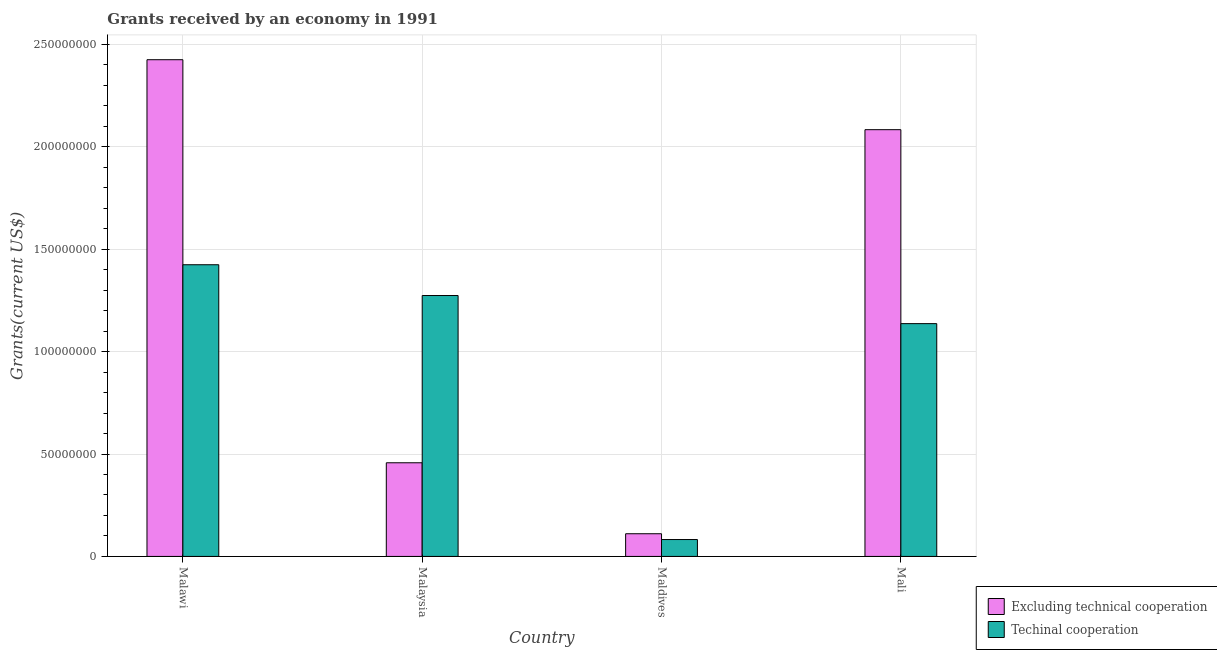Are the number of bars on each tick of the X-axis equal?
Your answer should be very brief. Yes. What is the label of the 2nd group of bars from the left?
Keep it short and to the point. Malaysia. What is the amount of grants received(excluding technical cooperation) in Mali?
Give a very brief answer. 2.08e+08. Across all countries, what is the maximum amount of grants received(excluding technical cooperation)?
Give a very brief answer. 2.43e+08. Across all countries, what is the minimum amount of grants received(including technical cooperation)?
Your answer should be compact. 8.25e+06. In which country was the amount of grants received(including technical cooperation) maximum?
Keep it short and to the point. Malawi. In which country was the amount of grants received(excluding technical cooperation) minimum?
Offer a very short reply. Maldives. What is the total amount of grants received(excluding technical cooperation) in the graph?
Provide a succinct answer. 5.08e+08. What is the difference between the amount of grants received(including technical cooperation) in Malaysia and that in Maldives?
Keep it short and to the point. 1.19e+08. What is the difference between the amount of grants received(excluding technical cooperation) in Maldives and the amount of grants received(including technical cooperation) in Mali?
Ensure brevity in your answer.  -1.03e+08. What is the average amount of grants received(including technical cooperation) per country?
Provide a succinct answer. 9.80e+07. What is the difference between the amount of grants received(excluding technical cooperation) and amount of grants received(including technical cooperation) in Mali?
Your answer should be compact. 9.47e+07. In how many countries, is the amount of grants received(excluding technical cooperation) greater than 190000000 US$?
Offer a terse response. 2. What is the ratio of the amount of grants received(including technical cooperation) in Malawi to that in Mali?
Provide a short and direct response. 1.25. Is the amount of grants received(including technical cooperation) in Malawi less than that in Mali?
Your response must be concise. No. What is the difference between the highest and the second highest amount of grants received(excluding technical cooperation)?
Your answer should be very brief. 3.42e+07. What is the difference between the highest and the lowest amount of grants received(including technical cooperation)?
Your response must be concise. 1.34e+08. What does the 1st bar from the left in Maldives represents?
Ensure brevity in your answer.  Excluding technical cooperation. What does the 2nd bar from the right in Malaysia represents?
Provide a succinct answer. Excluding technical cooperation. How many bars are there?
Ensure brevity in your answer.  8. Are all the bars in the graph horizontal?
Keep it short and to the point. No. How many countries are there in the graph?
Your response must be concise. 4. Are the values on the major ticks of Y-axis written in scientific E-notation?
Ensure brevity in your answer.  No. Does the graph contain any zero values?
Offer a very short reply. No. Where does the legend appear in the graph?
Your answer should be very brief. Bottom right. How are the legend labels stacked?
Provide a short and direct response. Vertical. What is the title of the graph?
Your answer should be compact. Grants received by an economy in 1991. What is the label or title of the Y-axis?
Ensure brevity in your answer.  Grants(current US$). What is the Grants(current US$) in Excluding technical cooperation in Malawi?
Offer a very short reply. 2.43e+08. What is the Grants(current US$) in Techinal cooperation in Malawi?
Ensure brevity in your answer.  1.42e+08. What is the Grants(current US$) of Excluding technical cooperation in Malaysia?
Keep it short and to the point. 4.57e+07. What is the Grants(current US$) in Techinal cooperation in Malaysia?
Keep it short and to the point. 1.27e+08. What is the Grants(current US$) in Excluding technical cooperation in Maldives?
Offer a terse response. 1.11e+07. What is the Grants(current US$) of Techinal cooperation in Maldives?
Provide a succinct answer. 8.25e+06. What is the Grants(current US$) of Excluding technical cooperation in Mali?
Your answer should be compact. 2.08e+08. What is the Grants(current US$) in Techinal cooperation in Mali?
Make the answer very short. 1.14e+08. Across all countries, what is the maximum Grants(current US$) in Excluding technical cooperation?
Your response must be concise. 2.43e+08. Across all countries, what is the maximum Grants(current US$) of Techinal cooperation?
Ensure brevity in your answer.  1.42e+08. Across all countries, what is the minimum Grants(current US$) in Excluding technical cooperation?
Give a very brief answer. 1.11e+07. Across all countries, what is the minimum Grants(current US$) in Techinal cooperation?
Provide a short and direct response. 8.25e+06. What is the total Grants(current US$) in Excluding technical cooperation in the graph?
Keep it short and to the point. 5.08e+08. What is the total Grants(current US$) in Techinal cooperation in the graph?
Offer a very short reply. 3.92e+08. What is the difference between the Grants(current US$) in Excluding technical cooperation in Malawi and that in Malaysia?
Your answer should be compact. 1.97e+08. What is the difference between the Grants(current US$) of Techinal cooperation in Malawi and that in Malaysia?
Your answer should be compact. 1.50e+07. What is the difference between the Grants(current US$) of Excluding technical cooperation in Malawi and that in Maldives?
Keep it short and to the point. 2.32e+08. What is the difference between the Grants(current US$) of Techinal cooperation in Malawi and that in Maldives?
Keep it short and to the point. 1.34e+08. What is the difference between the Grants(current US$) of Excluding technical cooperation in Malawi and that in Mali?
Offer a terse response. 3.42e+07. What is the difference between the Grants(current US$) of Techinal cooperation in Malawi and that in Mali?
Provide a short and direct response. 2.88e+07. What is the difference between the Grants(current US$) of Excluding technical cooperation in Malaysia and that in Maldives?
Offer a terse response. 3.47e+07. What is the difference between the Grants(current US$) of Techinal cooperation in Malaysia and that in Maldives?
Ensure brevity in your answer.  1.19e+08. What is the difference between the Grants(current US$) of Excluding technical cooperation in Malaysia and that in Mali?
Your response must be concise. -1.63e+08. What is the difference between the Grants(current US$) in Techinal cooperation in Malaysia and that in Mali?
Offer a very short reply. 1.37e+07. What is the difference between the Grants(current US$) in Excluding technical cooperation in Maldives and that in Mali?
Ensure brevity in your answer.  -1.97e+08. What is the difference between the Grants(current US$) of Techinal cooperation in Maldives and that in Mali?
Your answer should be compact. -1.05e+08. What is the difference between the Grants(current US$) of Excluding technical cooperation in Malawi and the Grants(current US$) of Techinal cooperation in Malaysia?
Your answer should be very brief. 1.15e+08. What is the difference between the Grants(current US$) in Excluding technical cooperation in Malawi and the Grants(current US$) in Techinal cooperation in Maldives?
Offer a terse response. 2.34e+08. What is the difference between the Grants(current US$) of Excluding technical cooperation in Malawi and the Grants(current US$) of Techinal cooperation in Mali?
Offer a terse response. 1.29e+08. What is the difference between the Grants(current US$) of Excluding technical cooperation in Malaysia and the Grants(current US$) of Techinal cooperation in Maldives?
Your answer should be very brief. 3.75e+07. What is the difference between the Grants(current US$) in Excluding technical cooperation in Malaysia and the Grants(current US$) in Techinal cooperation in Mali?
Your answer should be very brief. -6.80e+07. What is the difference between the Grants(current US$) in Excluding technical cooperation in Maldives and the Grants(current US$) in Techinal cooperation in Mali?
Ensure brevity in your answer.  -1.03e+08. What is the average Grants(current US$) in Excluding technical cooperation per country?
Give a very brief answer. 1.27e+08. What is the average Grants(current US$) of Techinal cooperation per country?
Ensure brevity in your answer.  9.80e+07. What is the difference between the Grants(current US$) in Excluding technical cooperation and Grants(current US$) in Techinal cooperation in Malawi?
Ensure brevity in your answer.  1.00e+08. What is the difference between the Grants(current US$) of Excluding technical cooperation and Grants(current US$) of Techinal cooperation in Malaysia?
Keep it short and to the point. -8.17e+07. What is the difference between the Grants(current US$) in Excluding technical cooperation and Grants(current US$) in Techinal cooperation in Maldives?
Make the answer very short. 2.83e+06. What is the difference between the Grants(current US$) in Excluding technical cooperation and Grants(current US$) in Techinal cooperation in Mali?
Provide a short and direct response. 9.47e+07. What is the ratio of the Grants(current US$) of Excluding technical cooperation in Malawi to that in Malaysia?
Give a very brief answer. 5.3. What is the ratio of the Grants(current US$) of Techinal cooperation in Malawi to that in Malaysia?
Your response must be concise. 1.12. What is the ratio of the Grants(current US$) in Excluding technical cooperation in Malawi to that in Maldives?
Your response must be concise. 21.89. What is the ratio of the Grants(current US$) in Techinal cooperation in Malawi to that in Maldives?
Make the answer very short. 17.27. What is the ratio of the Grants(current US$) in Excluding technical cooperation in Malawi to that in Mali?
Give a very brief answer. 1.16. What is the ratio of the Grants(current US$) in Techinal cooperation in Malawi to that in Mali?
Provide a succinct answer. 1.25. What is the ratio of the Grants(current US$) of Excluding technical cooperation in Malaysia to that in Maldives?
Give a very brief answer. 4.13. What is the ratio of the Grants(current US$) in Techinal cooperation in Malaysia to that in Maldives?
Your response must be concise. 15.44. What is the ratio of the Grants(current US$) in Excluding technical cooperation in Malaysia to that in Mali?
Provide a short and direct response. 0.22. What is the ratio of the Grants(current US$) in Techinal cooperation in Malaysia to that in Mali?
Your answer should be compact. 1.12. What is the ratio of the Grants(current US$) of Excluding technical cooperation in Maldives to that in Mali?
Your answer should be very brief. 0.05. What is the ratio of the Grants(current US$) of Techinal cooperation in Maldives to that in Mali?
Provide a short and direct response. 0.07. What is the difference between the highest and the second highest Grants(current US$) of Excluding technical cooperation?
Provide a succinct answer. 3.42e+07. What is the difference between the highest and the second highest Grants(current US$) of Techinal cooperation?
Give a very brief answer. 1.50e+07. What is the difference between the highest and the lowest Grants(current US$) in Excluding technical cooperation?
Offer a very short reply. 2.32e+08. What is the difference between the highest and the lowest Grants(current US$) of Techinal cooperation?
Keep it short and to the point. 1.34e+08. 